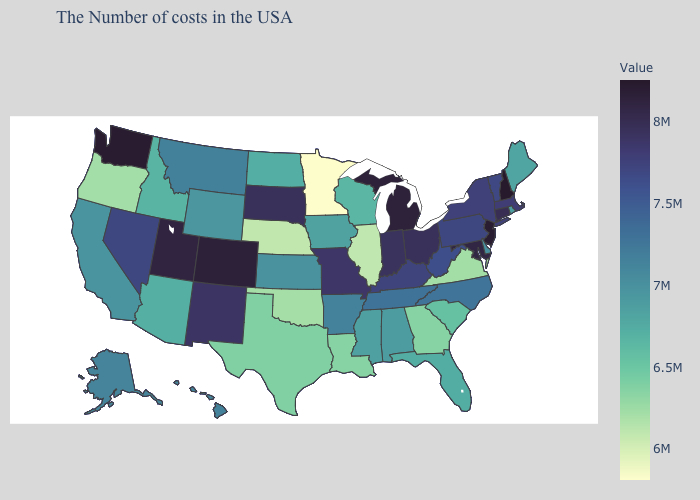Among the states that border Maryland , does Pennsylvania have the highest value?
Answer briefly. Yes. Does Maine have the highest value in the Northeast?
Write a very short answer. No. Is the legend a continuous bar?
Keep it brief. Yes. Among the states that border Connecticut , does Massachusetts have the lowest value?
Write a very short answer. No. 